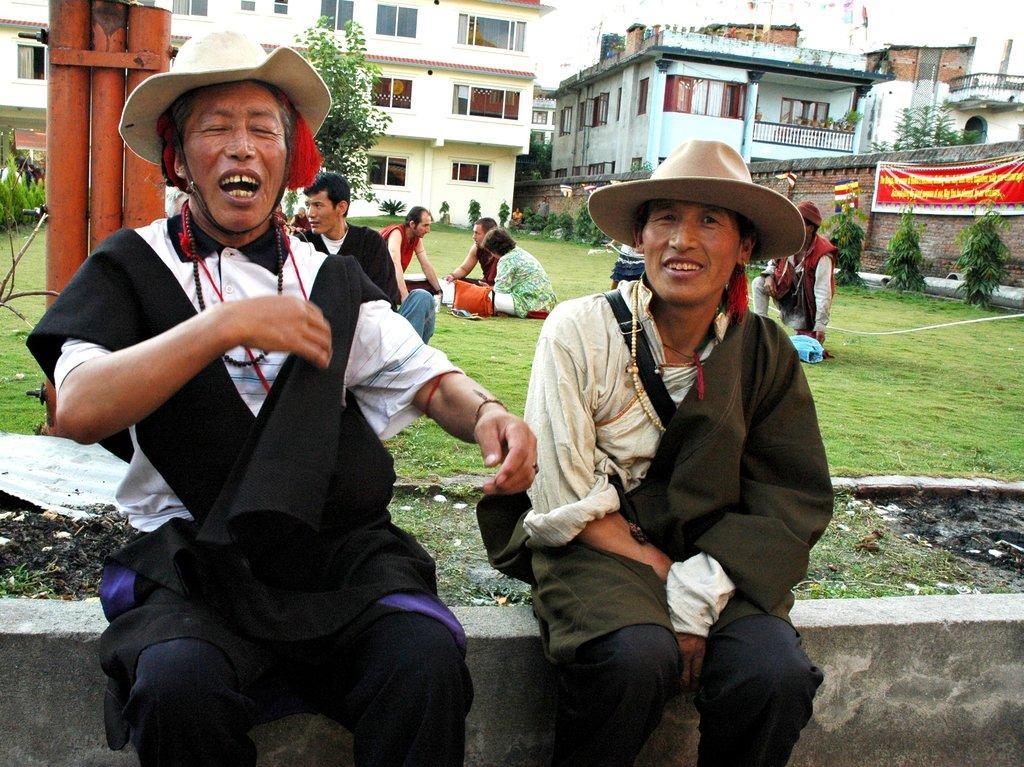Can you describe this image briefly? In this picture there are two persons who are sitting on the wall. Behind them I can see some people were sitting on the grass. In the background I can see the buildings, trees, plants and grass. On the right there is a banner which is placed near to the wall. At the top I can see the sky and clouds. 